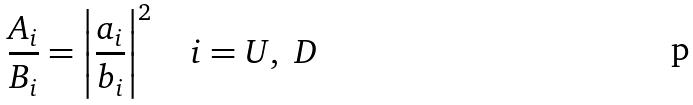<formula> <loc_0><loc_0><loc_500><loc_500>\frac { A _ { i } } { B _ { i } } = \left | \frac { a _ { i } } { b _ { i } } \right | ^ { 2 } \quad i = U , \ D</formula> 